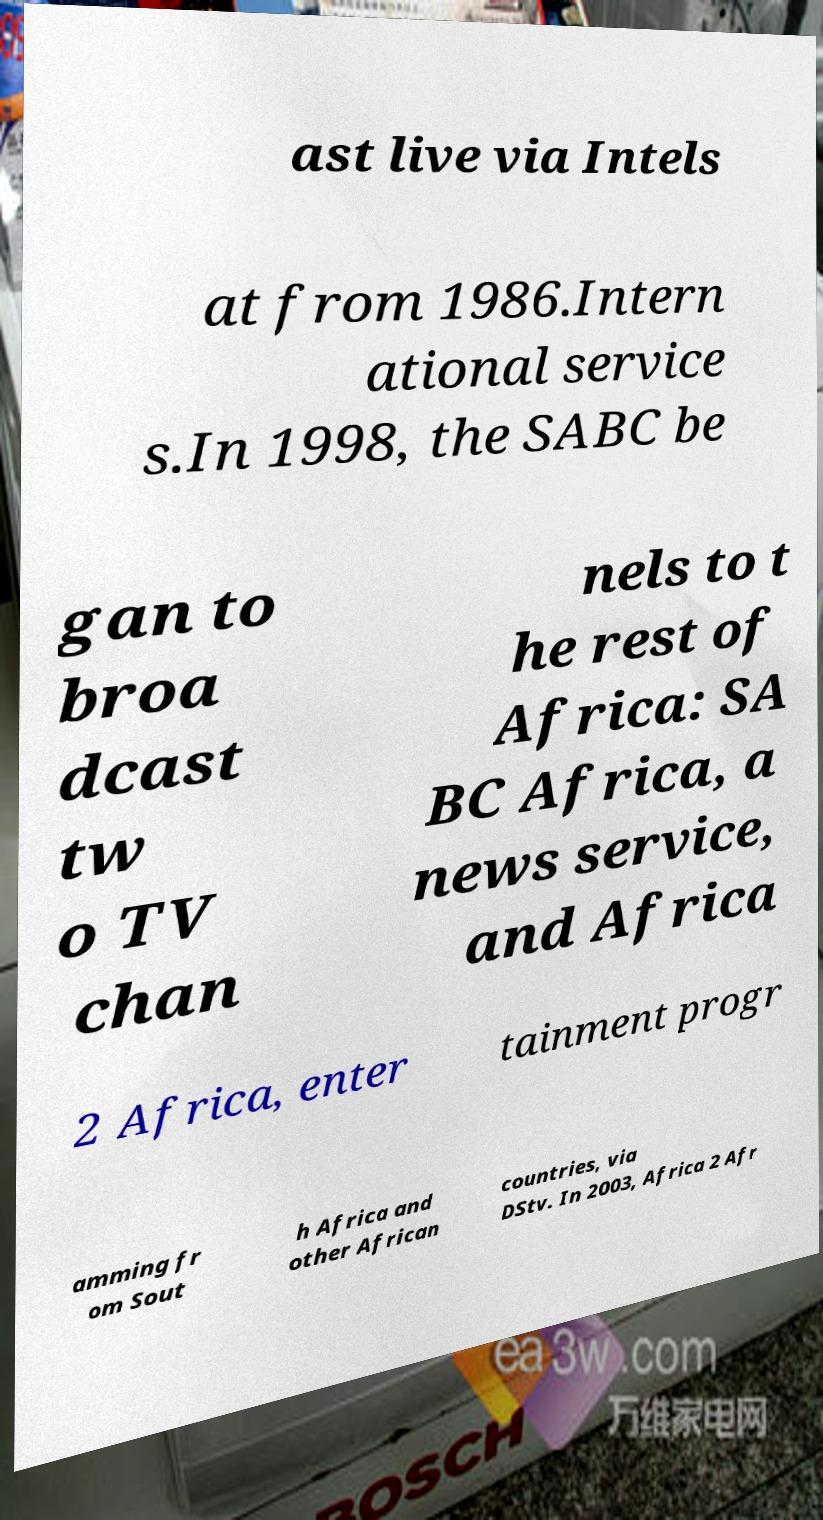I need the written content from this picture converted into text. Can you do that? ast live via Intels at from 1986.Intern ational service s.In 1998, the SABC be gan to broa dcast tw o TV chan nels to t he rest of Africa: SA BC Africa, a news service, and Africa 2 Africa, enter tainment progr amming fr om Sout h Africa and other African countries, via DStv. In 2003, Africa 2 Afr 